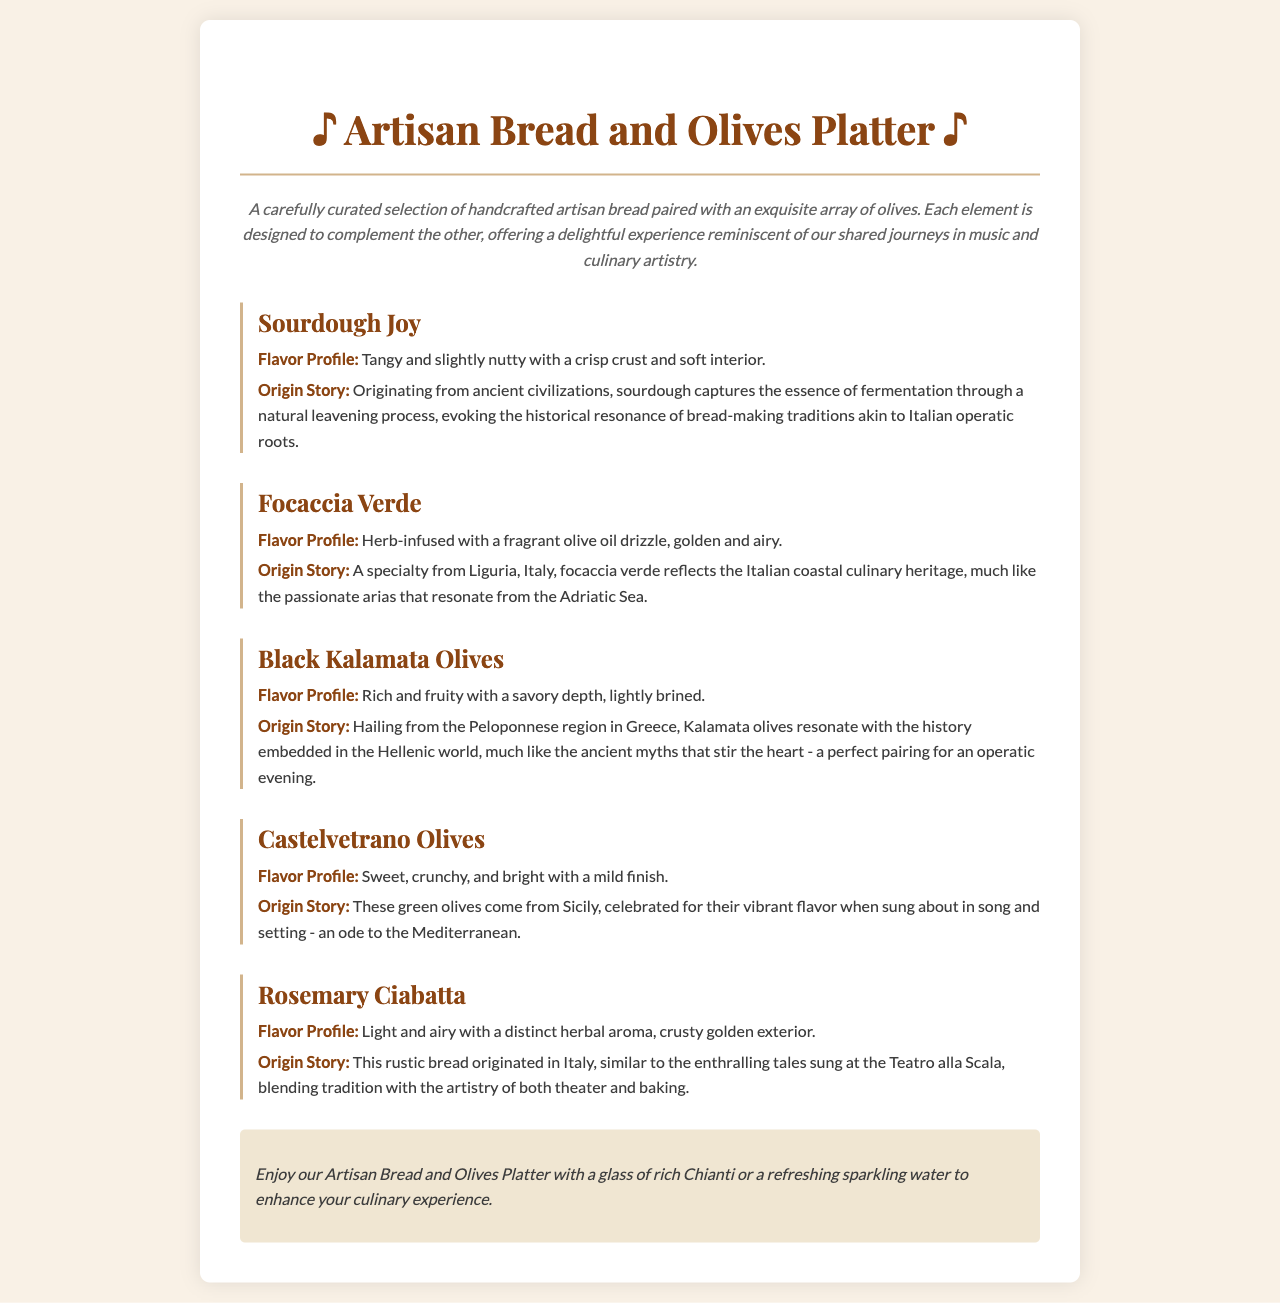what is the name of the platter? The platter is titled "Artisan Bread and Olives Platter."
Answer: Artisan Bread and Olives Platter what are the ingredients in the platter? The ingredients include handcrafted artisan bread and an array of olives.
Answer: handcrafted artisan bread and an array of olives what is the flavor profile of Sourdough Joy? The flavor profile describes Sourdough Joy as "tangy and slightly nutty with a crisp crust and soft interior."
Answer: tangy and slightly nutty with a crisp crust and soft interior where does Focaccia Verde originate? Focaccia Verde is a specialty from Liguria, Italy.
Answer: Liguria, Italy which olive is described as "sweet, crunchy, and bright"? Castelvetrano Olives are described as "sweet, crunchy, and bright."
Answer: Castelvetrano Olives what drink is suggested to enhance the platter experience? The suggested drink to enhance the experience is a glass of rich Chianti or refreshing sparkling water.
Answer: glass of rich Chianti or refreshing sparkling water why is Sourdough associated with Italian operatic roots? Sourdough's origin story links it to fermentation traditions that evoke historical resonance similar to Italian opera.
Answer: historical resonance of bread-making traditions akin to Italian operatic roots what is the texture of Rosemary Ciabatta? The texture description of Rosemary Ciabatta states it is "light and airy with a distinct herbal aroma."
Answer: light and airy with a distinct herbal aroma how would you describe the brining of Black Kalamata Olives? Black Kalamata Olives are described as "lightly brined."
Answer: lightly brined 